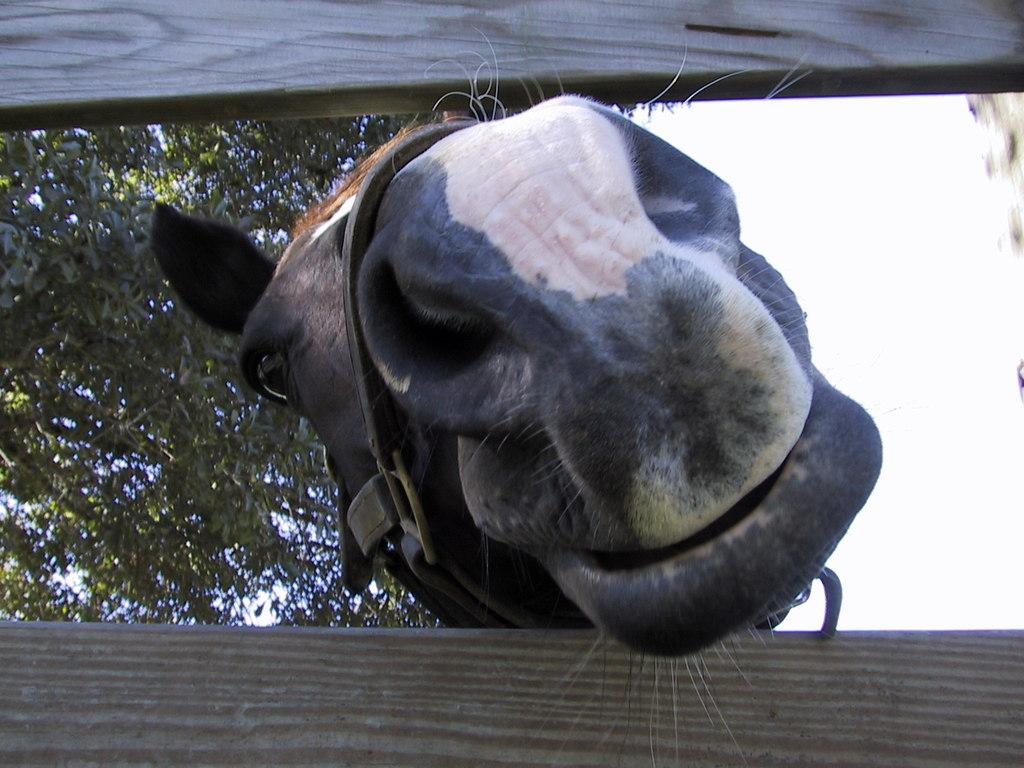What animal is present in the image? There is a horse in the image. What colors can be seen on the horse? The horse is black and white in color. What type of material is visible in the image? There is a wooden sheet in the image. What type of plant can be seen in the image? There is a tree in the image. What is the color of the sky in the image? The sky is white in the image. What type of bed can be seen in the image? There is no bed present in the image; it features a horse, a wooden sheet, a tree, and a white sky. 